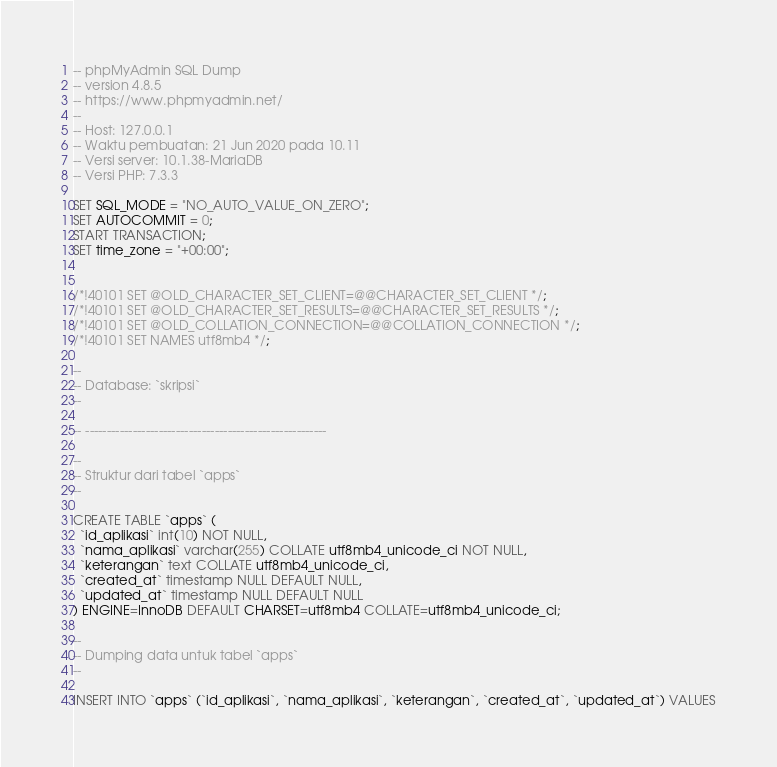Convert code to text. <code><loc_0><loc_0><loc_500><loc_500><_SQL_>-- phpMyAdmin SQL Dump
-- version 4.8.5
-- https://www.phpmyadmin.net/
--
-- Host: 127.0.0.1
-- Waktu pembuatan: 21 Jun 2020 pada 10.11
-- Versi server: 10.1.38-MariaDB
-- Versi PHP: 7.3.3

SET SQL_MODE = "NO_AUTO_VALUE_ON_ZERO";
SET AUTOCOMMIT = 0;
START TRANSACTION;
SET time_zone = "+00:00";


/*!40101 SET @OLD_CHARACTER_SET_CLIENT=@@CHARACTER_SET_CLIENT */;
/*!40101 SET @OLD_CHARACTER_SET_RESULTS=@@CHARACTER_SET_RESULTS */;
/*!40101 SET @OLD_COLLATION_CONNECTION=@@COLLATION_CONNECTION */;
/*!40101 SET NAMES utf8mb4 */;

--
-- Database: `skripsi`
--

-- --------------------------------------------------------

--
-- Struktur dari tabel `apps`
--

CREATE TABLE `apps` (
  `id_aplikasi` int(10) NOT NULL,
  `nama_aplikasi` varchar(255) COLLATE utf8mb4_unicode_ci NOT NULL,
  `keterangan` text COLLATE utf8mb4_unicode_ci,
  `created_at` timestamp NULL DEFAULT NULL,
  `updated_at` timestamp NULL DEFAULT NULL
) ENGINE=InnoDB DEFAULT CHARSET=utf8mb4 COLLATE=utf8mb4_unicode_ci;

--
-- Dumping data untuk tabel `apps`
--

INSERT INTO `apps` (`id_aplikasi`, `nama_aplikasi`, `keterangan`, `created_at`, `updated_at`) VALUES</code> 